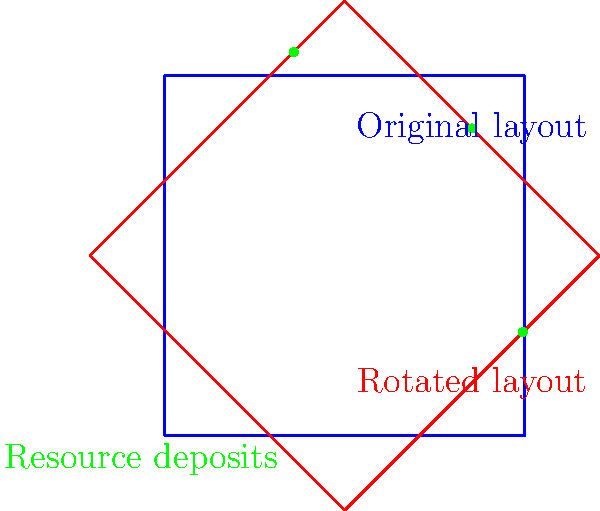A square-shaped mine site layout needs to be rotated to optimize resource extraction. The current layout is represented by the blue square, and three major resource deposits are shown as green dots. If the site is rotated 45° clockwise around its center to maximize access to the deposits (as shown by the red square), what is the transformation matrix that represents this rotation? To solve this problem, we need to follow these steps:

1) Recall the general form of a 2D rotation matrix for a counterclockwise rotation by angle $\theta$:

   $$R(\theta) = \begin{bmatrix} \cos\theta & -\sin\theta \\ \sin\theta & \cos\theta \end{bmatrix}$$

2) In this case, we're rotating 45° clockwise, which is equivalent to rotating -45° counterclockwise. So, we need to use $\theta = -45°$ or $-\frac{\pi}{4}$ radians.

3) Calculate $\cos(-45°)$ and $\sin(-45°)$:
   
   $\cos(-45°) = \cos(45°) = \frac{\sqrt{2}}{2}$
   
   $\sin(-45°) = -\sin(45°) = -\frac{\sqrt{2}}{2}$

4) Substitute these values into the rotation matrix:

   $$R(-45°) = \begin{bmatrix} \cos(-45°) & -\sin(-45°) \\ \sin(-45°) & \cos(-45°) \end{bmatrix}$$

   $$= \begin{bmatrix} \frac{\sqrt{2}}{2} & \frac{\sqrt{2}}{2} \\ -\frac{\sqrt{2}}{2} & \frac{\sqrt{2}}{2} \end{bmatrix}$$

This matrix represents the transformation that rotates the mine site layout by 45° clockwise around its center, optimizing access to the resource deposits.
Answer: $$\begin{bmatrix} \frac{\sqrt{2}}{2} & \frac{\sqrt{2}}{2} \\ -\frac{\sqrt{2}}{2} & \frac{\sqrt{2}}{2} \end{bmatrix}$$ 